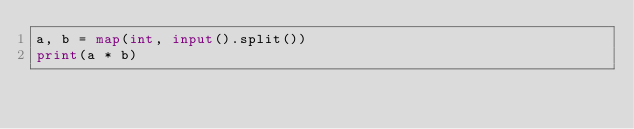Convert code to text. <code><loc_0><loc_0><loc_500><loc_500><_Python_>a, b = map(int, input().split())
print(a * b)</code> 